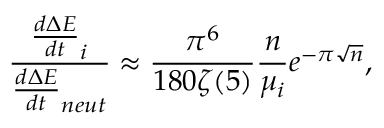Convert formula to latex. <formula><loc_0><loc_0><loc_500><loc_500>\frac { \frac { d \Delta E } { d t } _ { i } } { \frac { d \Delta E } { d t } _ { n e u t } } \approx \frac { \pi ^ { 6 } } { 1 8 0 \zeta ( 5 ) } \frac { n } { \mu _ { i } } e ^ { - \pi \sqrt { n } } ,</formula> 